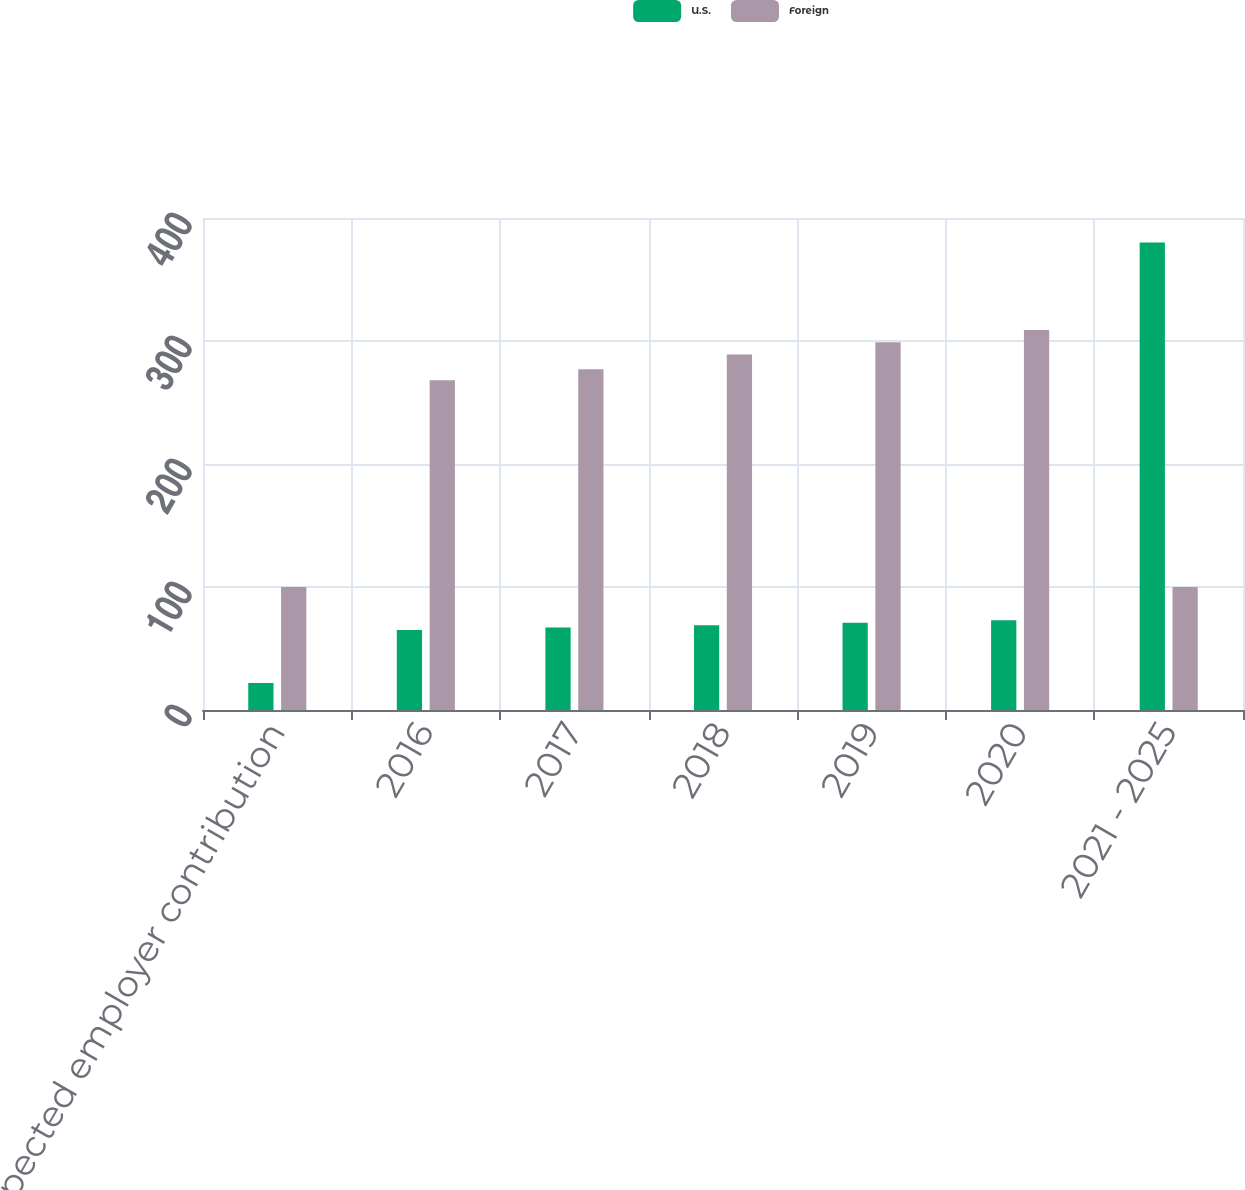Convert chart to OTSL. <chart><loc_0><loc_0><loc_500><loc_500><stacked_bar_chart><ecel><fcel>Expected employer contribution<fcel>2016<fcel>2017<fcel>2018<fcel>2019<fcel>2020<fcel>2021 - 2025<nl><fcel>U.S.<fcel>22<fcel>65<fcel>67<fcel>69<fcel>71<fcel>73<fcel>380<nl><fcel>Foreign<fcel>100<fcel>268<fcel>277<fcel>289<fcel>299<fcel>309<fcel>100<nl></chart> 